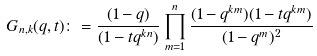Convert formula to latex. <formula><loc_0><loc_0><loc_500><loc_500>G _ { n , k } ( q , t ) \colon = \frac { ( 1 - q ) } { ( 1 - t q ^ { k n } ) } \prod _ { m = 1 } ^ { n } \frac { ( 1 - q ^ { k m } ) ( 1 - t q ^ { k m } ) } { ( 1 - q ^ { m } ) ^ { 2 } }</formula> 